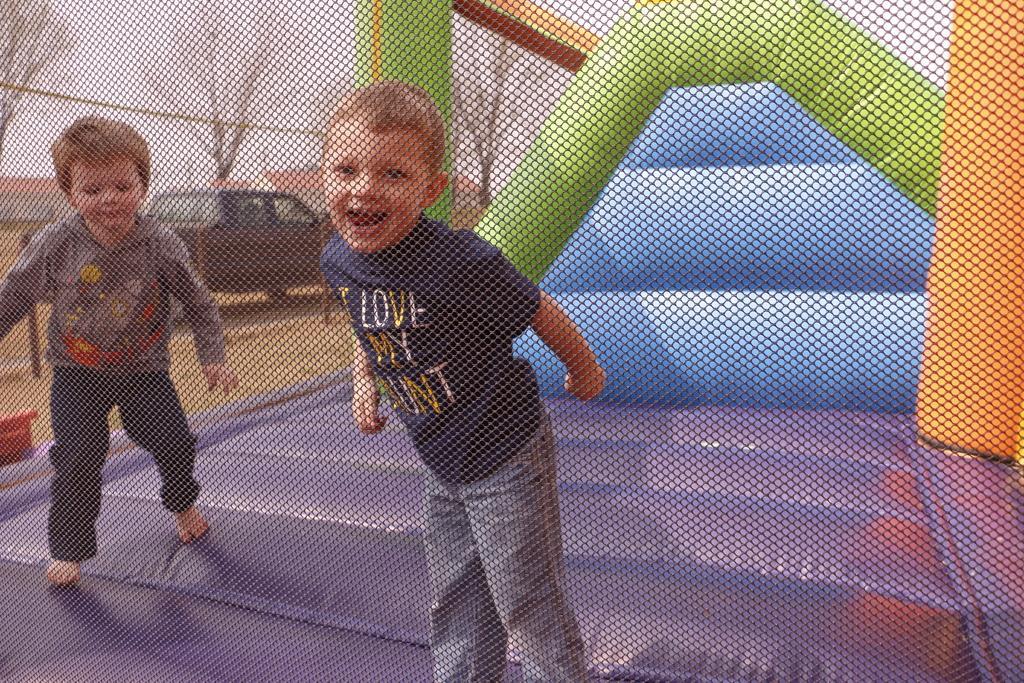Could you give a brief overview of what you see in this image? In this image we can see two kids on the inflatable bouncing, there are some trees, poles, buildings and a vehicle, in the background, we can see the sky. 